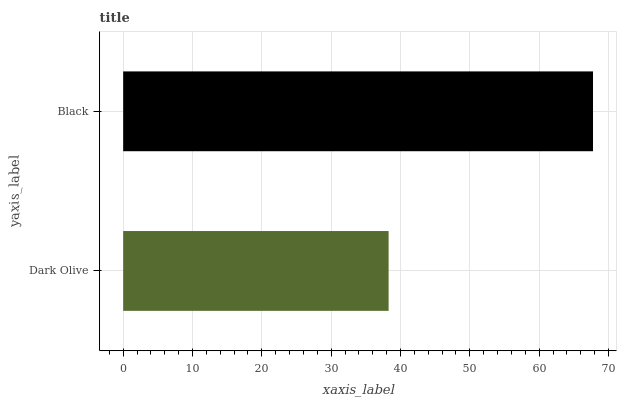Is Dark Olive the minimum?
Answer yes or no. Yes. Is Black the maximum?
Answer yes or no. Yes. Is Black the minimum?
Answer yes or no. No. Is Black greater than Dark Olive?
Answer yes or no. Yes. Is Dark Olive less than Black?
Answer yes or no. Yes. Is Dark Olive greater than Black?
Answer yes or no. No. Is Black less than Dark Olive?
Answer yes or no. No. Is Black the high median?
Answer yes or no. Yes. Is Dark Olive the low median?
Answer yes or no. Yes. Is Dark Olive the high median?
Answer yes or no. No. Is Black the low median?
Answer yes or no. No. 